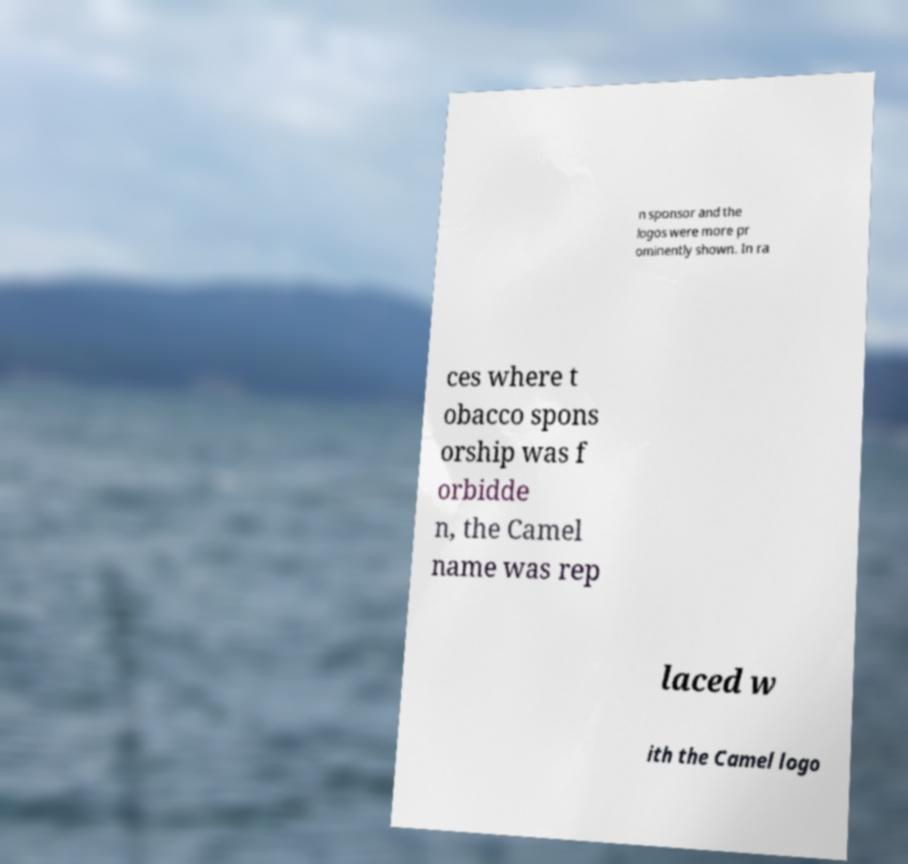What messages or text are displayed in this image? I need them in a readable, typed format. n sponsor and the logos were more pr ominently shown. In ra ces where t obacco spons orship was f orbidde n, the Camel name was rep laced w ith the Camel logo 